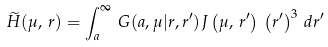<formula> <loc_0><loc_0><loc_500><loc_500>\widetilde { H } ( \mu , \, r ) = \int _ { a } ^ { \infty } \, G ( a , \mu | r , r ^ { \prime } ) J \left ( \mu , \, r ^ { \prime } \right ) \, \left ( r ^ { \prime } \right ) ^ { 3 } \, d r ^ { \prime }</formula> 